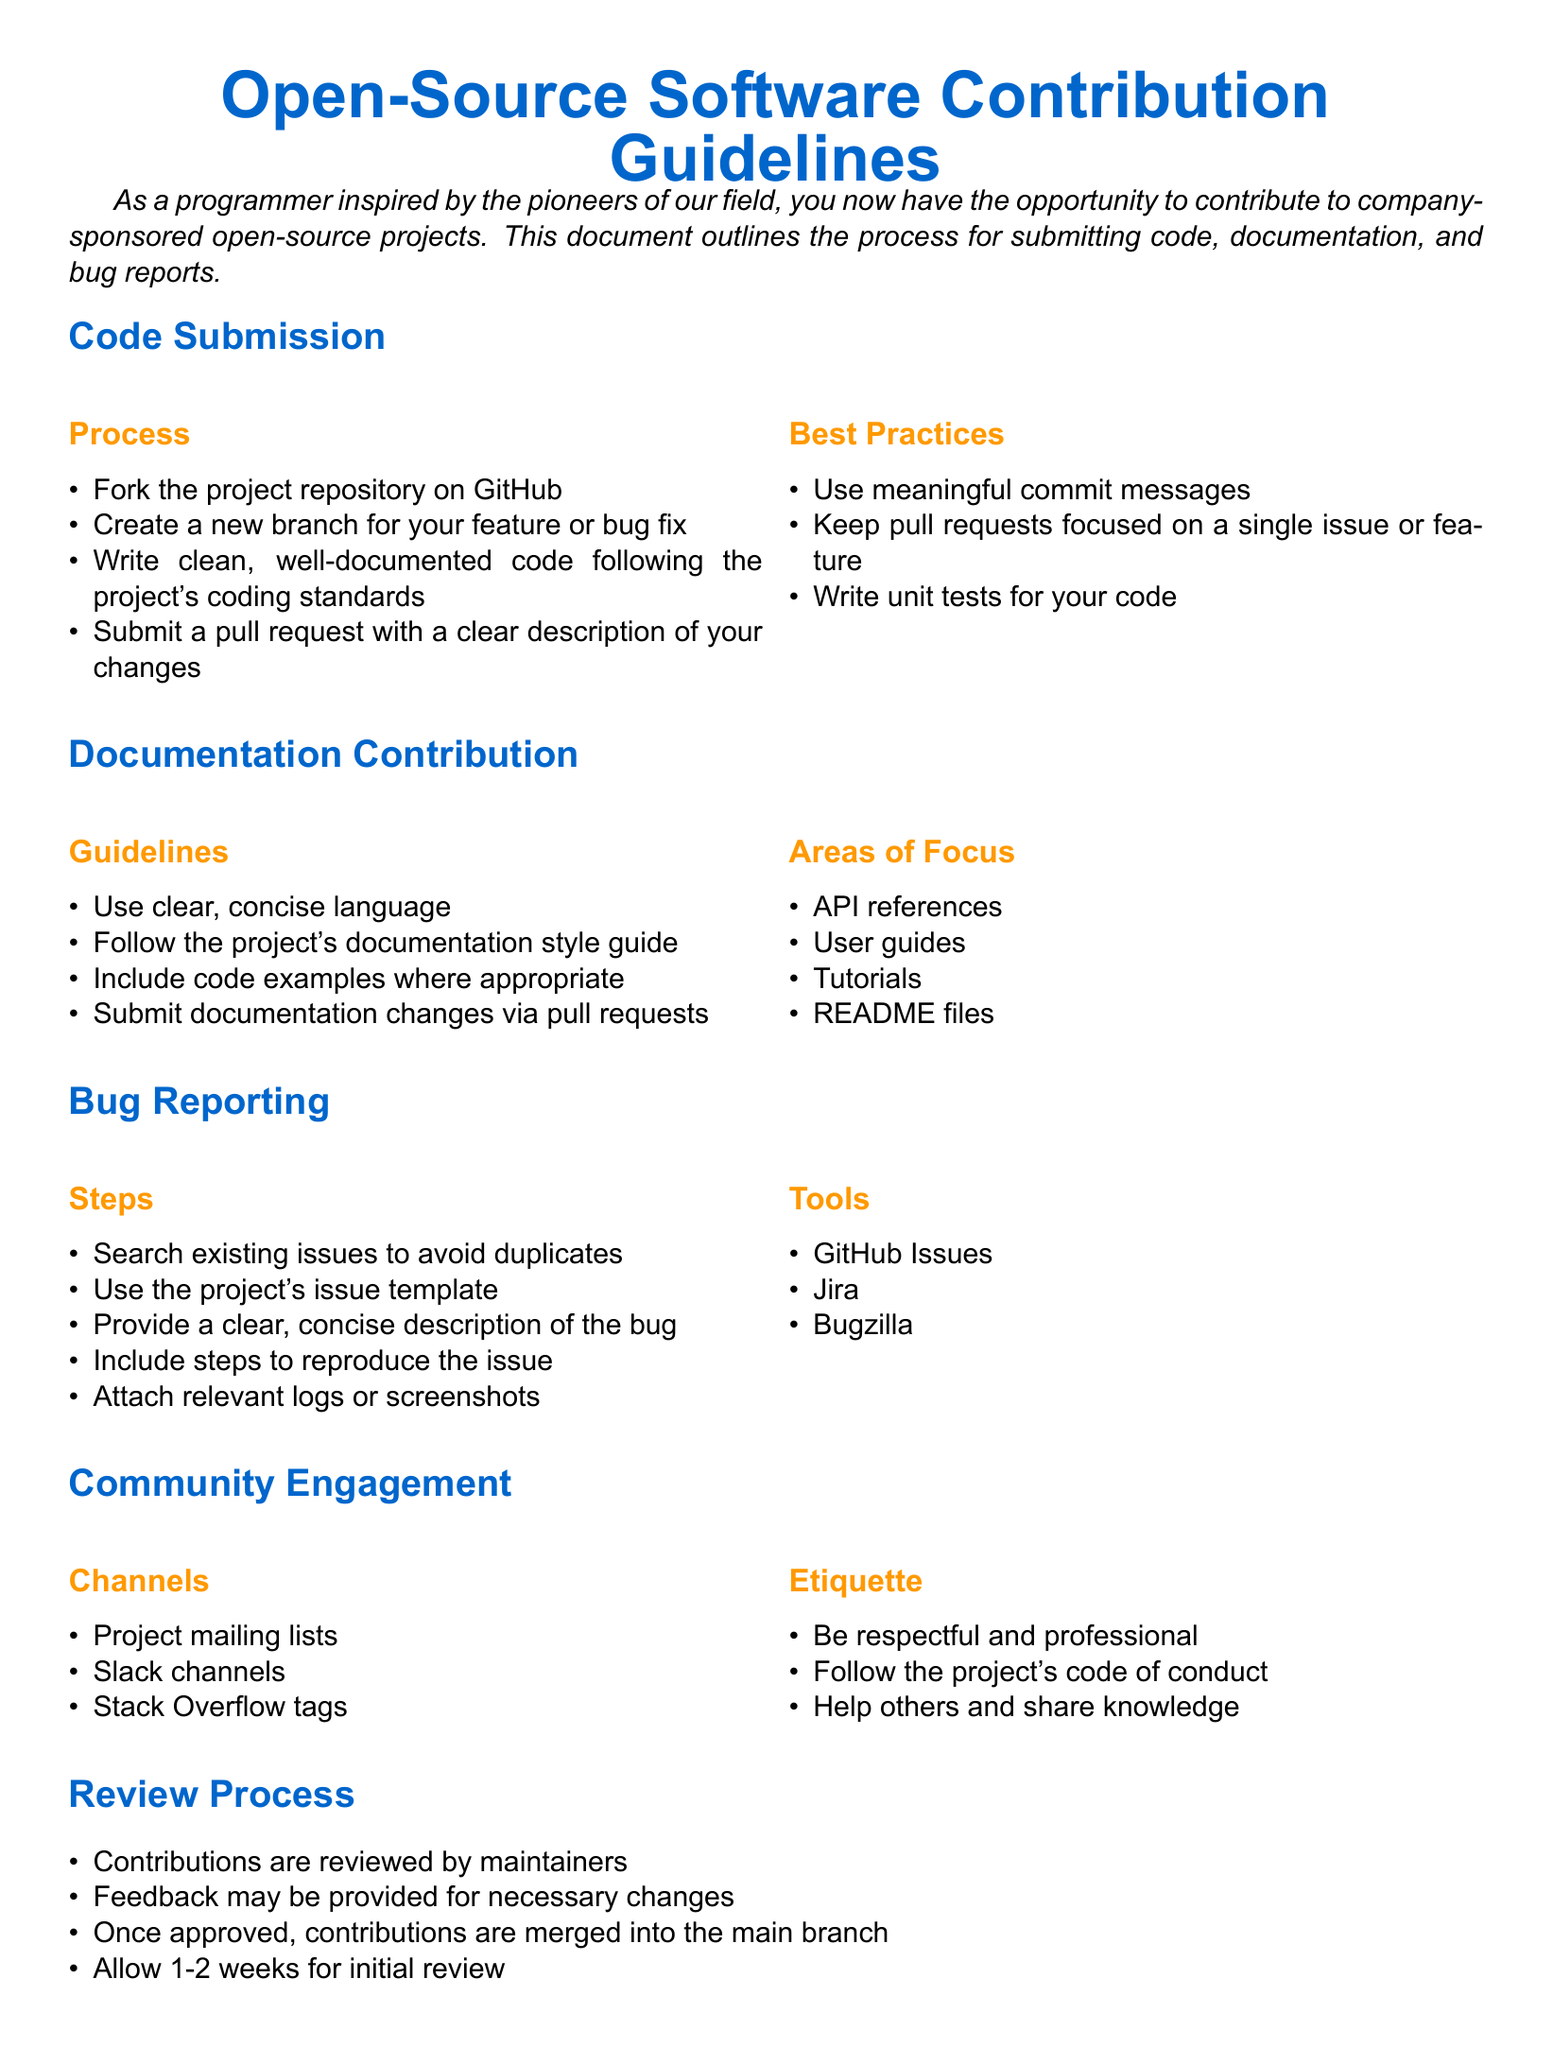What is the title of the document? The title of the document is emphasized at the beginning as the main subject presented.
Answer: Open-Source Software Contribution Guidelines What is the first step in the code submission process? The first step outlines the initial action required from contributors when submitting code.
Answer: Fork the project repository on GitHub What should documentation changes include? This includes the expected elements when submitting updates to the project's documentation.
Answer: Submit documentation changes via pull requests What tools are mentioned for bug reporting? The document specifies tools that can be utilized for reporting bugs within the project's framework.
Answer: GitHub Issues, Jira, Bugzilla How long should contributors allow for initial review of their submission? This indicates the timeframe maintainers may take to provide feedback on contributions.
Answer: 1-2 weeks What is a guideline for writing documentation? This points to a fundamental principle that should be followed in writing project documentation.
Answer: Use clear, concise language What channel is NOT listed for community engagement? This question requires reasoning to deduce which common communication channel is not mentioned.
Answer: None (all channels listed are endorsed) What should be included in a bug report's description? This indicates the key information that needs to be conveyed when reporting an issue.
Answer: A clear, concise description of the bug What is emphasized in the etiquette section? This encompasses the behavioral expectations from contributors to the community.
Answer: Be respectful and professional 